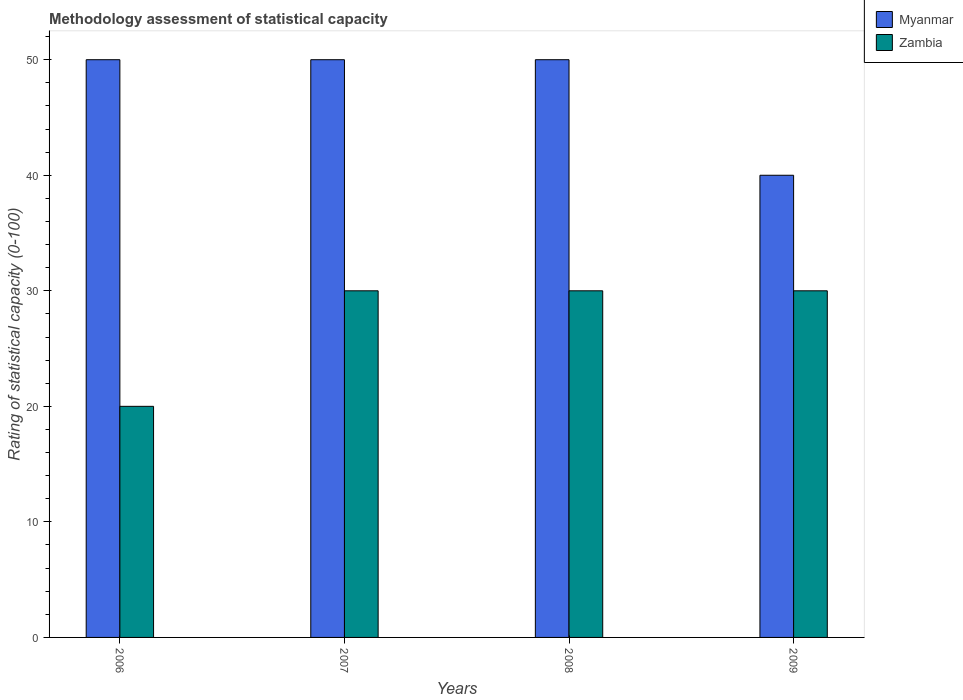Are the number of bars per tick equal to the number of legend labels?
Your answer should be compact. Yes. In how many cases, is the number of bars for a given year not equal to the number of legend labels?
Your answer should be very brief. 0. What is the rating of statistical capacity in Zambia in 2007?
Provide a succinct answer. 30. Across all years, what is the maximum rating of statistical capacity in Zambia?
Keep it short and to the point. 30. Across all years, what is the minimum rating of statistical capacity in Myanmar?
Provide a short and direct response. 40. In which year was the rating of statistical capacity in Myanmar minimum?
Make the answer very short. 2009. What is the total rating of statistical capacity in Myanmar in the graph?
Ensure brevity in your answer.  190. What is the difference between the rating of statistical capacity in Myanmar in 2008 and the rating of statistical capacity in Zambia in 2009?
Offer a very short reply. 20. What is the average rating of statistical capacity in Zambia per year?
Offer a very short reply. 27.5. In the year 2009, what is the difference between the rating of statistical capacity in Myanmar and rating of statistical capacity in Zambia?
Provide a short and direct response. 10. What is the ratio of the rating of statistical capacity in Myanmar in 2006 to that in 2009?
Make the answer very short. 1.25. What is the difference between the highest and the second highest rating of statistical capacity in Zambia?
Offer a terse response. 0. What is the difference between the highest and the lowest rating of statistical capacity in Zambia?
Your response must be concise. 10. In how many years, is the rating of statistical capacity in Zambia greater than the average rating of statistical capacity in Zambia taken over all years?
Keep it short and to the point. 3. What does the 1st bar from the left in 2006 represents?
Provide a succinct answer. Myanmar. What does the 2nd bar from the right in 2007 represents?
Offer a terse response. Myanmar. How many bars are there?
Offer a very short reply. 8. Are all the bars in the graph horizontal?
Offer a terse response. No. How many years are there in the graph?
Your answer should be very brief. 4. What is the difference between two consecutive major ticks on the Y-axis?
Your answer should be compact. 10. Does the graph contain any zero values?
Your answer should be very brief. No. How many legend labels are there?
Your answer should be compact. 2. How are the legend labels stacked?
Your answer should be very brief. Vertical. What is the title of the graph?
Make the answer very short. Methodology assessment of statistical capacity. Does "Australia" appear as one of the legend labels in the graph?
Your answer should be compact. No. What is the label or title of the Y-axis?
Provide a short and direct response. Rating of statistical capacity (0-100). What is the Rating of statistical capacity (0-100) of Zambia in 2006?
Give a very brief answer. 20. What is the Rating of statistical capacity (0-100) of Zambia in 2008?
Ensure brevity in your answer.  30. Across all years, what is the minimum Rating of statistical capacity (0-100) of Zambia?
Your answer should be very brief. 20. What is the total Rating of statistical capacity (0-100) in Myanmar in the graph?
Make the answer very short. 190. What is the total Rating of statistical capacity (0-100) in Zambia in the graph?
Provide a succinct answer. 110. What is the difference between the Rating of statistical capacity (0-100) in Myanmar in 2006 and that in 2007?
Your answer should be very brief. 0. What is the difference between the Rating of statistical capacity (0-100) in Zambia in 2006 and that in 2007?
Your answer should be compact. -10. What is the difference between the Rating of statistical capacity (0-100) in Myanmar in 2006 and that in 2008?
Your answer should be very brief. 0. What is the difference between the Rating of statistical capacity (0-100) of Myanmar in 2007 and that in 2008?
Provide a short and direct response. 0. What is the difference between the Rating of statistical capacity (0-100) of Zambia in 2007 and that in 2008?
Your answer should be compact. 0. What is the difference between the Rating of statistical capacity (0-100) of Zambia in 2007 and that in 2009?
Ensure brevity in your answer.  0. What is the difference between the Rating of statistical capacity (0-100) of Zambia in 2008 and that in 2009?
Make the answer very short. 0. What is the difference between the Rating of statistical capacity (0-100) in Myanmar in 2006 and the Rating of statistical capacity (0-100) in Zambia in 2007?
Offer a very short reply. 20. What is the difference between the Rating of statistical capacity (0-100) of Myanmar in 2006 and the Rating of statistical capacity (0-100) of Zambia in 2008?
Make the answer very short. 20. What is the difference between the Rating of statistical capacity (0-100) in Myanmar in 2007 and the Rating of statistical capacity (0-100) in Zambia in 2008?
Give a very brief answer. 20. What is the difference between the Rating of statistical capacity (0-100) in Myanmar in 2007 and the Rating of statistical capacity (0-100) in Zambia in 2009?
Offer a terse response. 20. What is the average Rating of statistical capacity (0-100) of Myanmar per year?
Provide a succinct answer. 47.5. What is the average Rating of statistical capacity (0-100) in Zambia per year?
Your answer should be very brief. 27.5. In the year 2009, what is the difference between the Rating of statistical capacity (0-100) in Myanmar and Rating of statistical capacity (0-100) in Zambia?
Your answer should be compact. 10. What is the ratio of the Rating of statistical capacity (0-100) of Myanmar in 2006 to that in 2008?
Your answer should be compact. 1. What is the ratio of the Rating of statistical capacity (0-100) in Zambia in 2006 to that in 2008?
Provide a short and direct response. 0.67. What is the ratio of the Rating of statistical capacity (0-100) of Zambia in 2006 to that in 2009?
Provide a succinct answer. 0.67. What is the ratio of the Rating of statistical capacity (0-100) of Zambia in 2007 to that in 2008?
Keep it short and to the point. 1. What is the ratio of the Rating of statistical capacity (0-100) in Zambia in 2007 to that in 2009?
Provide a succinct answer. 1. What is the ratio of the Rating of statistical capacity (0-100) of Myanmar in 2008 to that in 2009?
Your response must be concise. 1.25. What is the ratio of the Rating of statistical capacity (0-100) in Zambia in 2008 to that in 2009?
Offer a very short reply. 1. What is the difference between the highest and the lowest Rating of statistical capacity (0-100) in Myanmar?
Make the answer very short. 10. What is the difference between the highest and the lowest Rating of statistical capacity (0-100) in Zambia?
Make the answer very short. 10. 